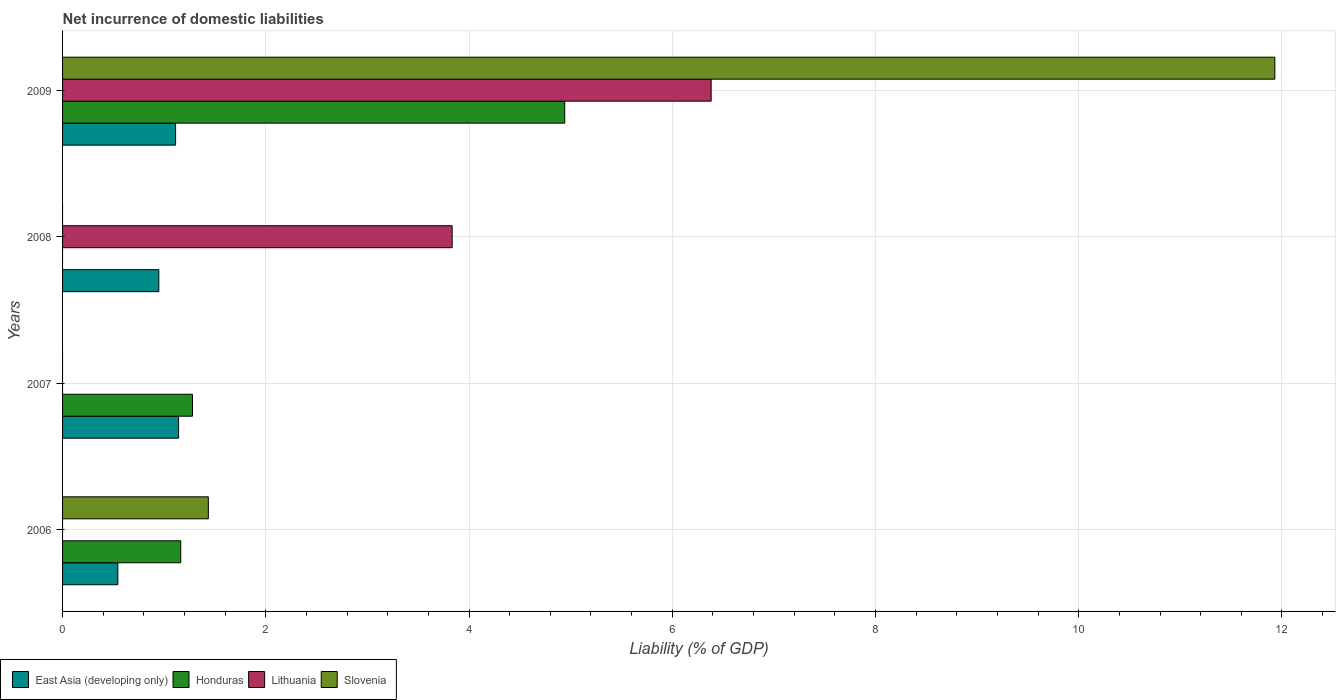How many bars are there on the 1st tick from the top?
Provide a short and direct response. 4. What is the net incurrence of domestic liabilities in Slovenia in 2006?
Your answer should be very brief. 1.43. Across all years, what is the maximum net incurrence of domestic liabilities in Honduras?
Your response must be concise. 4.94. Across all years, what is the minimum net incurrence of domestic liabilities in Slovenia?
Give a very brief answer. 0. In which year was the net incurrence of domestic liabilities in East Asia (developing only) maximum?
Offer a very short reply. 2007. What is the total net incurrence of domestic liabilities in Lithuania in the graph?
Offer a very short reply. 10.22. What is the difference between the net incurrence of domestic liabilities in East Asia (developing only) in 2006 and that in 2008?
Give a very brief answer. -0.4. What is the difference between the net incurrence of domestic liabilities in Honduras in 2006 and the net incurrence of domestic liabilities in East Asia (developing only) in 2007?
Provide a succinct answer. 0.02. What is the average net incurrence of domestic liabilities in East Asia (developing only) per year?
Offer a very short reply. 0.94. In the year 2008, what is the difference between the net incurrence of domestic liabilities in Lithuania and net incurrence of domestic liabilities in East Asia (developing only)?
Your answer should be compact. 2.89. In how many years, is the net incurrence of domestic liabilities in East Asia (developing only) greater than 11.2 %?
Keep it short and to the point. 0. What is the ratio of the net incurrence of domestic liabilities in East Asia (developing only) in 2006 to that in 2009?
Give a very brief answer. 0.49. What is the difference between the highest and the second highest net incurrence of domestic liabilities in Honduras?
Make the answer very short. 3.66. What is the difference between the highest and the lowest net incurrence of domestic liabilities in Lithuania?
Your response must be concise. 6.38. In how many years, is the net incurrence of domestic liabilities in East Asia (developing only) greater than the average net incurrence of domestic liabilities in East Asia (developing only) taken over all years?
Keep it short and to the point. 3. Is the sum of the net incurrence of domestic liabilities in East Asia (developing only) in 2008 and 2009 greater than the maximum net incurrence of domestic liabilities in Lithuania across all years?
Provide a succinct answer. No. Are the values on the major ticks of X-axis written in scientific E-notation?
Keep it short and to the point. No. Does the graph contain any zero values?
Keep it short and to the point. Yes. What is the title of the graph?
Keep it short and to the point. Net incurrence of domestic liabilities. Does "Bermuda" appear as one of the legend labels in the graph?
Offer a terse response. No. What is the label or title of the X-axis?
Your response must be concise. Liability (% of GDP). What is the Liability (% of GDP) of East Asia (developing only) in 2006?
Make the answer very short. 0.54. What is the Liability (% of GDP) in Honduras in 2006?
Offer a very short reply. 1.16. What is the Liability (% of GDP) of Lithuania in 2006?
Keep it short and to the point. 0. What is the Liability (% of GDP) in Slovenia in 2006?
Your response must be concise. 1.43. What is the Liability (% of GDP) in East Asia (developing only) in 2007?
Your answer should be very brief. 1.14. What is the Liability (% of GDP) of Honduras in 2007?
Offer a terse response. 1.28. What is the Liability (% of GDP) in Lithuania in 2007?
Your answer should be compact. 0. What is the Liability (% of GDP) in East Asia (developing only) in 2008?
Provide a short and direct response. 0.95. What is the Liability (% of GDP) of Honduras in 2008?
Offer a terse response. 0. What is the Liability (% of GDP) in Lithuania in 2008?
Offer a terse response. 3.83. What is the Liability (% of GDP) of Slovenia in 2008?
Keep it short and to the point. 0. What is the Liability (% of GDP) of East Asia (developing only) in 2009?
Make the answer very short. 1.11. What is the Liability (% of GDP) in Honduras in 2009?
Your response must be concise. 4.94. What is the Liability (% of GDP) of Lithuania in 2009?
Give a very brief answer. 6.38. What is the Liability (% of GDP) in Slovenia in 2009?
Ensure brevity in your answer.  11.93. Across all years, what is the maximum Liability (% of GDP) in East Asia (developing only)?
Offer a very short reply. 1.14. Across all years, what is the maximum Liability (% of GDP) of Honduras?
Provide a short and direct response. 4.94. Across all years, what is the maximum Liability (% of GDP) of Lithuania?
Offer a terse response. 6.38. Across all years, what is the maximum Liability (% of GDP) in Slovenia?
Provide a short and direct response. 11.93. Across all years, what is the minimum Liability (% of GDP) of East Asia (developing only)?
Provide a short and direct response. 0.54. Across all years, what is the minimum Liability (% of GDP) of Slovenia?
Ensure brevity in your answer.  0. What is the total Liability (% of GDP) of East Asia (developing only) in the graph?
Provide a short and direct response. 3.75. What is the total Liability (% of GDP) in Honduras in the graph?
Offer a very short reply. 7.38. What is the total Liability (% of GDP) of Lithuania in the graph?
Offer a terse response. 10.22. What is the total Liability (% of GDP) of Slovenia in the graph?
Offer a very short reply. 13.37. What is the difference between the Liability (% of GDP) in East Asia (developing only) in 2006 and that in 2007?
Offer a terse response. -0.6. What is the difference between the Liability (% of GDP) of Honduras in 2006 and that in 2007?
Ensure brevity in your answer.  -0.12. What is the difference between the Liability (% of GDP) in East Asia (developing only) in 2006 and that in 2008?
Provide a succinct answer. -0.4. What is the difference between the Liability (% of GDP) of East Asia (developing only) in 2006 and that in 2009?
Your response must be concise. -0.57. What is the difference between the Liability (% of GDP) in Honduras in 2006 and that in 2009?
Offer a very short reply. -3.78. What is the difference between the Liability (% of GDP) of Slovenia in 2006 and that in 2009?
Your answer should be compact. -10.5. What is the difference between the Liability (% of GDP) of East Asia (developing only) in 2007 and that in 2008?
Your answer should be compact. 0.19. What is the difference between the Liability (% of GDP) of East Asia (developing only) in 2007 and that in 2009?
Make the answer very short. 0.03. What is the difference between the Liability (% of GDP) of Honduras in 2007 and that in 2009?
Keep it short and to the point. -3.66. What is the difference between the Liability (% of GDP) of East Asia (developing only) in 2008 and that in 2009?
Give a very brief answer. -0.16. What is the difference between the Liability (% of GDP) of Lithuania in 2008 and that in 2009?
Give a very brief answer. -2.55. What is the difference between the Liability (% of GDP) in East Asia (developing only) in 2006 and the Liability (% of GDP) in Honduras in 2007?
Your response must be concise. -0.73. What is the difference between the Liability (% of GDP) in East Asia (developing only) in 2006 and the Liability (% of GDP) in Lithuania in 2008?
Your response must be concise. -3.29. What is the difference between the Liability (% of GDP) of Honduras in 2006 and the Liability (% of GDP) of Lithuania in 2008?
Make the answer very short. -2.67. What is the difference between the Liability (% of GDP) in East Asia (developing only) in 2006 and the Liability (% of GDP) in Honduras in 2009?
Provide a succinct answer. -4.4. What is the difference between the Liability (% of GDP) in East Asia (developing only) in 2006 and the Liability (% of GDP) in Lithuania in 2009?
Your answer should be compact. -5.84. What is the difference between the Liability (% of GDP) in East Asia (developing only) in 2006 and the Liability (% of GDP) in Slovenia in 2009?
Your response must be concise. -11.39. What is the difference between the Liability (% of GDP) of Honduras in 2006 and the Liability (% of GDP) of Lithuania in 2009?
Offer a very short reply. -5.22. What is the difference between the Liability (% of GDP) of Honduras in 2006 and the Liability (% of GDP) of Slovenia in 2009?
Your response must be concise. -10.77. What is the difference between the Liability (% of GDP) in East Asia (developing only) in 2007 and the Liability (% of GDP) in Lithuania in 2008?
Offer a terse response. -2.69. What is the difference between the Liability (% of GDP) of Honduras in 2007 and the Liability (% of GDP) of Lithuania in 2008?
Offer a very short reply. -2.56. What is the difference between the Liability (% of GDP) in East Asia (developing only) in 2007 and the Liability (% of GDP) in Lithuania in 2009?
Your answer should be very brief. -5.24. What is the difference between the Liability (% of GDP) in East Asia (developing only) in 2007 and the Liability (% of GDP) in Slovenia in 2009?
Offer a terse response. -10.79. What is the difference between the Liability (% of GDP) in Honduras in 2007 and the Liability (% of GDP) in Lithuania in 2009?
Offer a very short reply. -5.1. What is the difference between the Liability (% of GDP) in Honduras in 2007 and the Liability (% of GDP) in Slovenia in 2009?
Ensure brevity in your answer.  -10.65. What is the difference between the Liability (% of GDP) of East Asia (developing only) in 2008 and the Liability (% of GDP) of Honduras in 2009?
Offer a terse response. -3.99. What is the difference between the Liability (% of GDP) in East Asia (developing only) in 2008 and the Liability (% of GDP) in Lithuania in 2009?
Give a very brief answer. -5.44. What is the difference between the Liability (% of GDP) of East Asia (developing only) in 2008 and the Liability (% of GDP) of Slovenia in 2009?
Provide a short and direct response. -10.98. What is the difference between the Liability (% of GDP) in Lithuania in 2008 and the Liability (% of GDP) in Slovenia in 2009?
Make the answer very short. -8.1. What is the average Liability (% of GDP) of East Asia (developing only) per year?
Keep it short and to the point. 0.94. What is the average Liability (% of GDP) of Honduras per year?
Provide a short and direct response. 1.85. What is the average Liability (% of GDP) of Lithuania per year?
Your answer should be compact. 2.55. What is the average Liability (% of GDP) in Slovenia per year?
Give a very brief answer. 3.34. In the year 2006, what is the difference between the Liability (% of GDP) of East Asia (developing only) and Liability (% of GDP) of Honduras?
Ensure brevity in your answer.  -0.62. In the year 2006, what is the difference between the Liability (% of GDP) in East Asia (developing only) and Liability (% of GDP) in Slovenia?
Your answer should be very brief. -0.89. In the year 2006, what is the difference between the Liability (% of GDP) of Honduras and Liability (% of GDP) of Slovenia?
Your answer should be compact. -0.27. In the year 2007, what is the difference between the Liability (% of GDP) in East Asia (developing only) and Liability (% of GDP) in Honduras?
Ensure brevity in your answer.  -0.14. In the year 2008, what is the difference between the Liability (% of GDP) of East Asia (developing only) and Liability (% of GDP) of Lithuania?
Your response must be concise. -2.89. In the year 2009, what is the difference between the Liability (% of GDP) in East Asia (developing only) and Liability (% of GDP) in Honduras?
Keep it short and to the point. -3.83. In the year 2009, what is the difference between the Liability (% of GDP) in East Asia (developing only) and Liability (% of GDP) in Lithuania?
Keep it short and to the point. -5.27. In the year 2009, what is the difference between the Liability (% of GDP) of East Asia (developing only) and Liability (% of GDP) of Slovenia?
Your response must be concise. -10.82. In the year 2009, what is the difference between the Liability (% of GDP) of Honduras and Liability (% of GDP) of Lithuania?
Provide a short and direct response. -1.44. In the year 2009, what is the difference between the Liability (% of GDP) in Honduras and Liability (% of GDP) in Slovenia?
Make the answer very short. -6.99. In the year 2009, what is the difference between the Liability (% of GDP) in Lithuania and Liability (% of GDP) in Slovenia?
Provide a short and direct response. -5.55. What is the ratio of the Liability (% of GDP) of East Asia (developing only) in 2006 to that in 2007?
Your answer should be compact. 0.48. What is the ratio of the Liability (% of GDP) in Honduras in 2006 to that in 2007?
Give a very brief answer. 0.91. What is the ratio of the Liability (% of GDP) in East Asia (developing only) in 2006 to that in 2008?
Your response must be concise. 0.57. What is the ratio of the Liability (% of GDP) of East Asia (developing only) in 2006 to that in 2009?
Make the answer very short. 0.49. What is the ratio of the Liability (% of GDP) of Honduras in 2006 to that in 2009?
Give a very brief answer. 0.24. What is the ratio of the Liability (% of GDP) in Slovenia in 2006 to that in 2009?
Your response must be concise. 0.12. What is the ratio of the Liability (% of GDP) of East Asia (developing only) in 2007 to that in 2008?
Provide a short and direct response. 1.21. What is the ratio of the Liability (% of GDP) of East Asia (developing only) in 2007 to that in 2009?
Offer a very short reply. 1.03. What is the ratio of the Liability (% of GDP) in Honduras in 2007 to that in 2009?
Offer a very short reply. 0.26. What is the ratio of the Liability (% of GDP) of East Asia (developing only) in 2008 to that in 2009?
Your answer should be compact. 0.85. What is the ratio of the Liability (% of GDP) of Lithuania in 2008 to that in 2009?
Your response must be concise. 0.6. What is the difference between the highest and the second highest Liability (% of GDP) in East Asia (developing only)?
Keep it short and to the point. 0.03. What is the difference between the highest and the second highest Liability (% of GDP) of Honduras?
Ensure brevity in your answer.  3.66. What is the difference between the highest and the lowest Liability (% of GDP) of East Asia (developing only)?
Keep it short and to the point. 0.6. What is the difference between the highest and the lowest Liability (% of GDP) in Honduras?
Your answer should be very brief. 4.94. What is the difference between the highest and the lowest Liability (% of GDP) of Lithuania?
Your answer should be compact. 6.38. What is the difference between the highest and the lowest Liability (% of GDP) in Slovenia?
Provide a short and direct response. 11.93. 